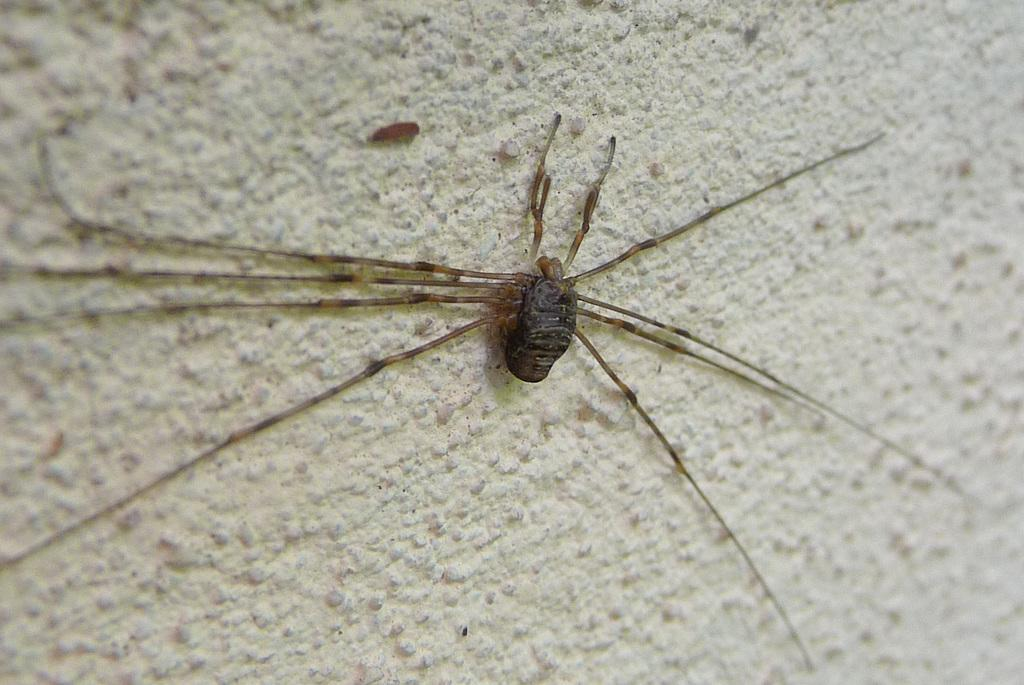What is the main subject of the image? There is a spider in the image. Can you describe the spiders have specific colors? Yes, the spider in the image is brown-colored. Where is the spider located in the image? The spider is on a wall. What rule does the spider's father enforce in the image? There is no mention of a father or any rules in the image; it only features a brown-colored spider on a wall. 